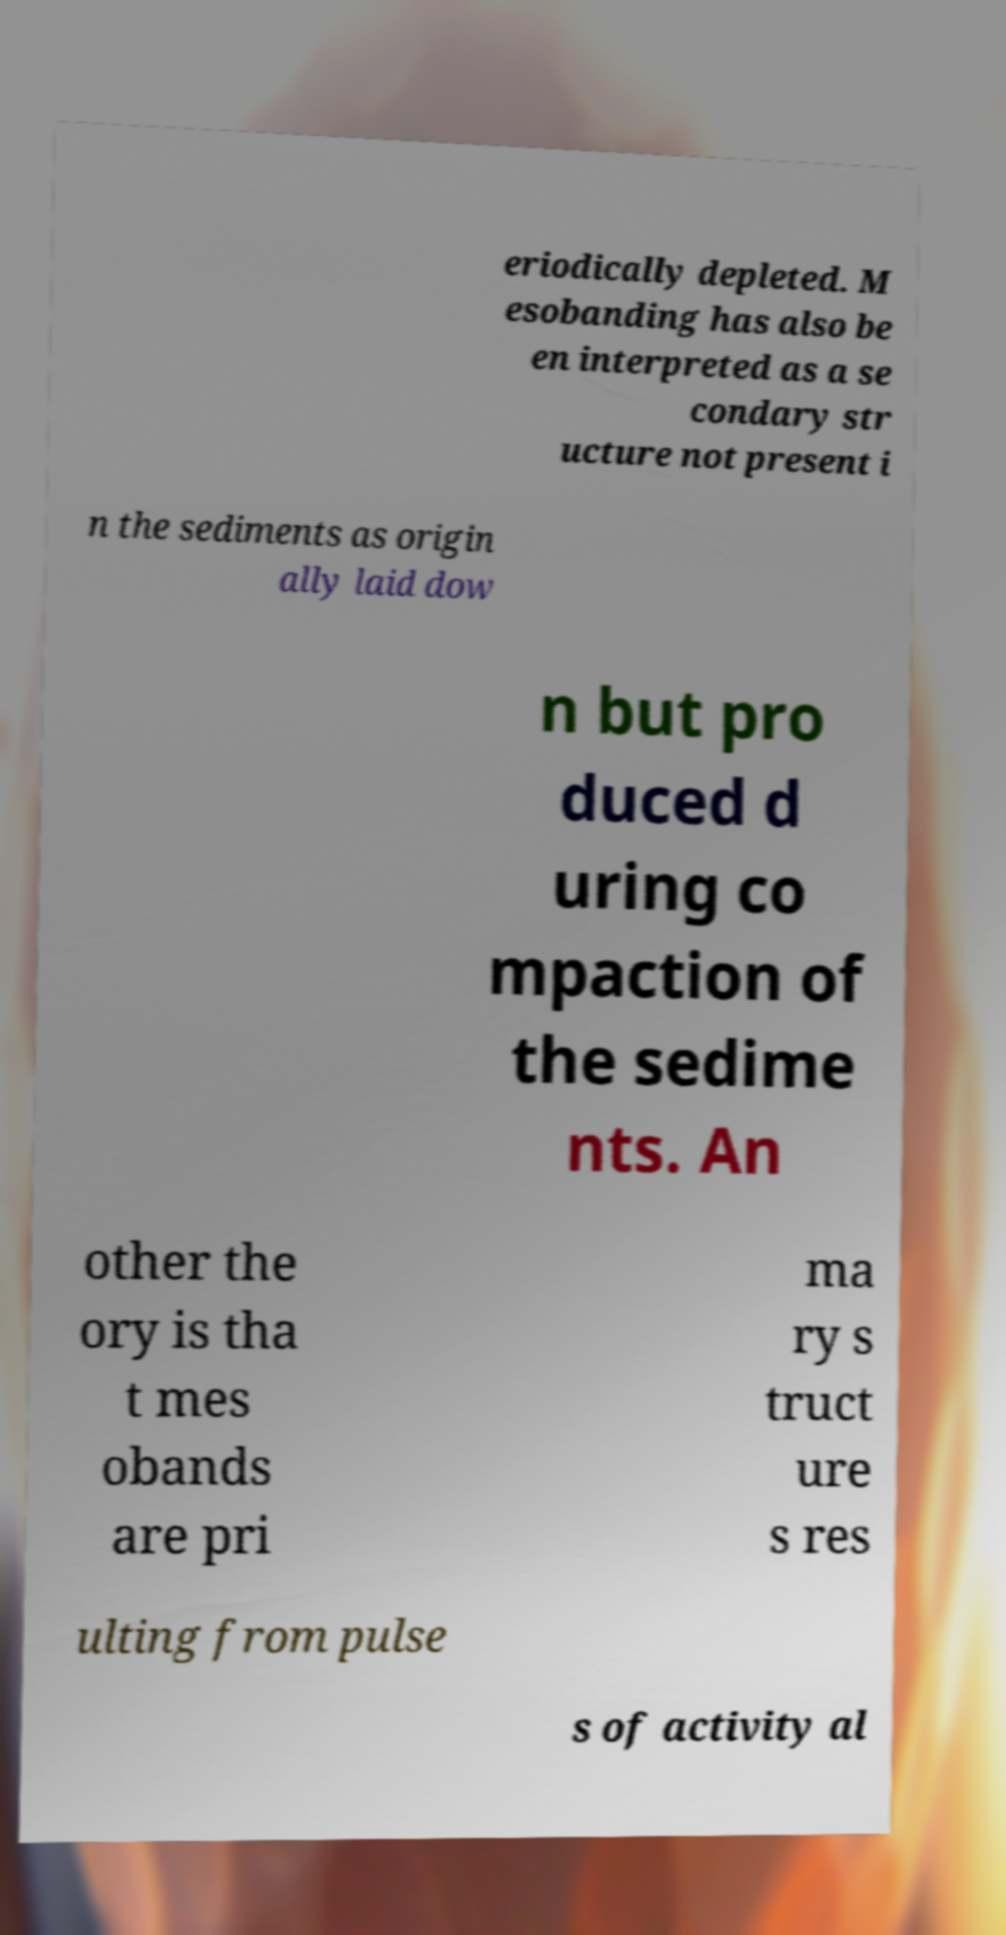Please read and relay the text visible in this image. What does it say? eriodically depleted. M esobanding has also be en interpreted as a se condary str ucture not present i n the sediments as origin ally laid dow n but pro duced d uring co mpaction of the sedime nts. An other the ory is tha t mes obands are pri ma ry s truct ure s res ulting from pulse s of activity al 